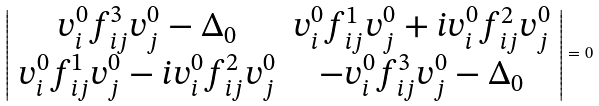Convert formula to latex. <formula><loc_0><loc_0><loc_500><loc_500>\left | \begin{array} { c c } v _ { i } ^ { 0 } f _ { i j } ^ { 3 } v _ { j } ^ { 0 } - \Delta _ { 0 } & v _ { i } ^ { 0 } f _ { i j } ^ { 1 } v _ { j } ^ { 0 } + i v _ { i } ^ { 0 } f _ { i j } ^ { 2 } v _ { j } ^ { 0 } \\ v _ { i } ^ { 0 } f _ { i j } ^ { 1 } v _ { j } ^ { 0 } - i v _ { i } ^ { 0 } f _ { i j } ^ { 2 } v _ { j } ^ { 0 } & - v _ { i } ^ { 0 } f _ { i j } ^ { 3 } v _ { j } ^ { 0 } - \Delta _ { 0 } \end{array} \right | = 0</formula> 